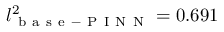Convert formula to latex. <formula><loc_0><loc_0><loc_500><loc_500>l _ { b a s e - P I N N } ^ { 2 } = 0 . 6 9 1</formula> 